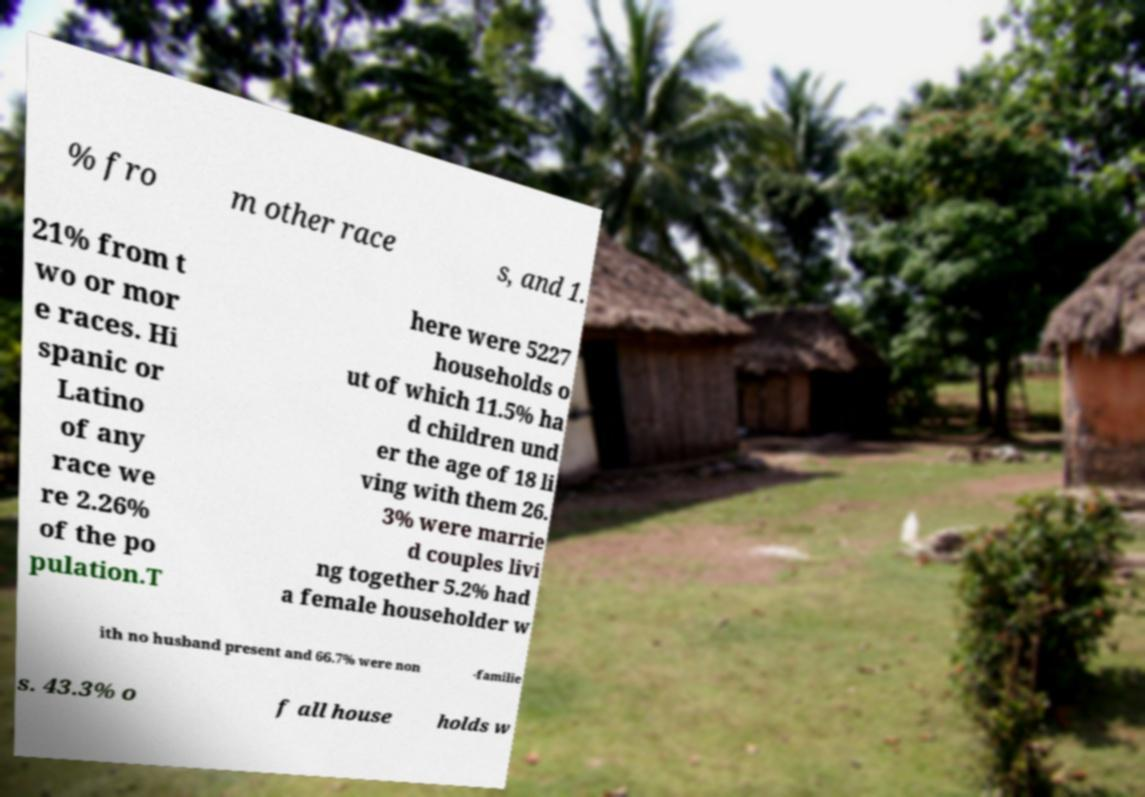Can you accurately transcribe the text from the provided image for me? % fro m other race s, and 1. 21% from t wo or mor e races. Hi spanic or Latino of any race we re 2.26% of the po pulation.T here were 5227 households o ut of which 11.5% ha d children und er the age of 18 li ving with them 26. 3% were marrie d couples livi ng together 5.2% had a female householder w ith no husband present and 66.7% were non -familie s. 43.3% o f all house holds w 